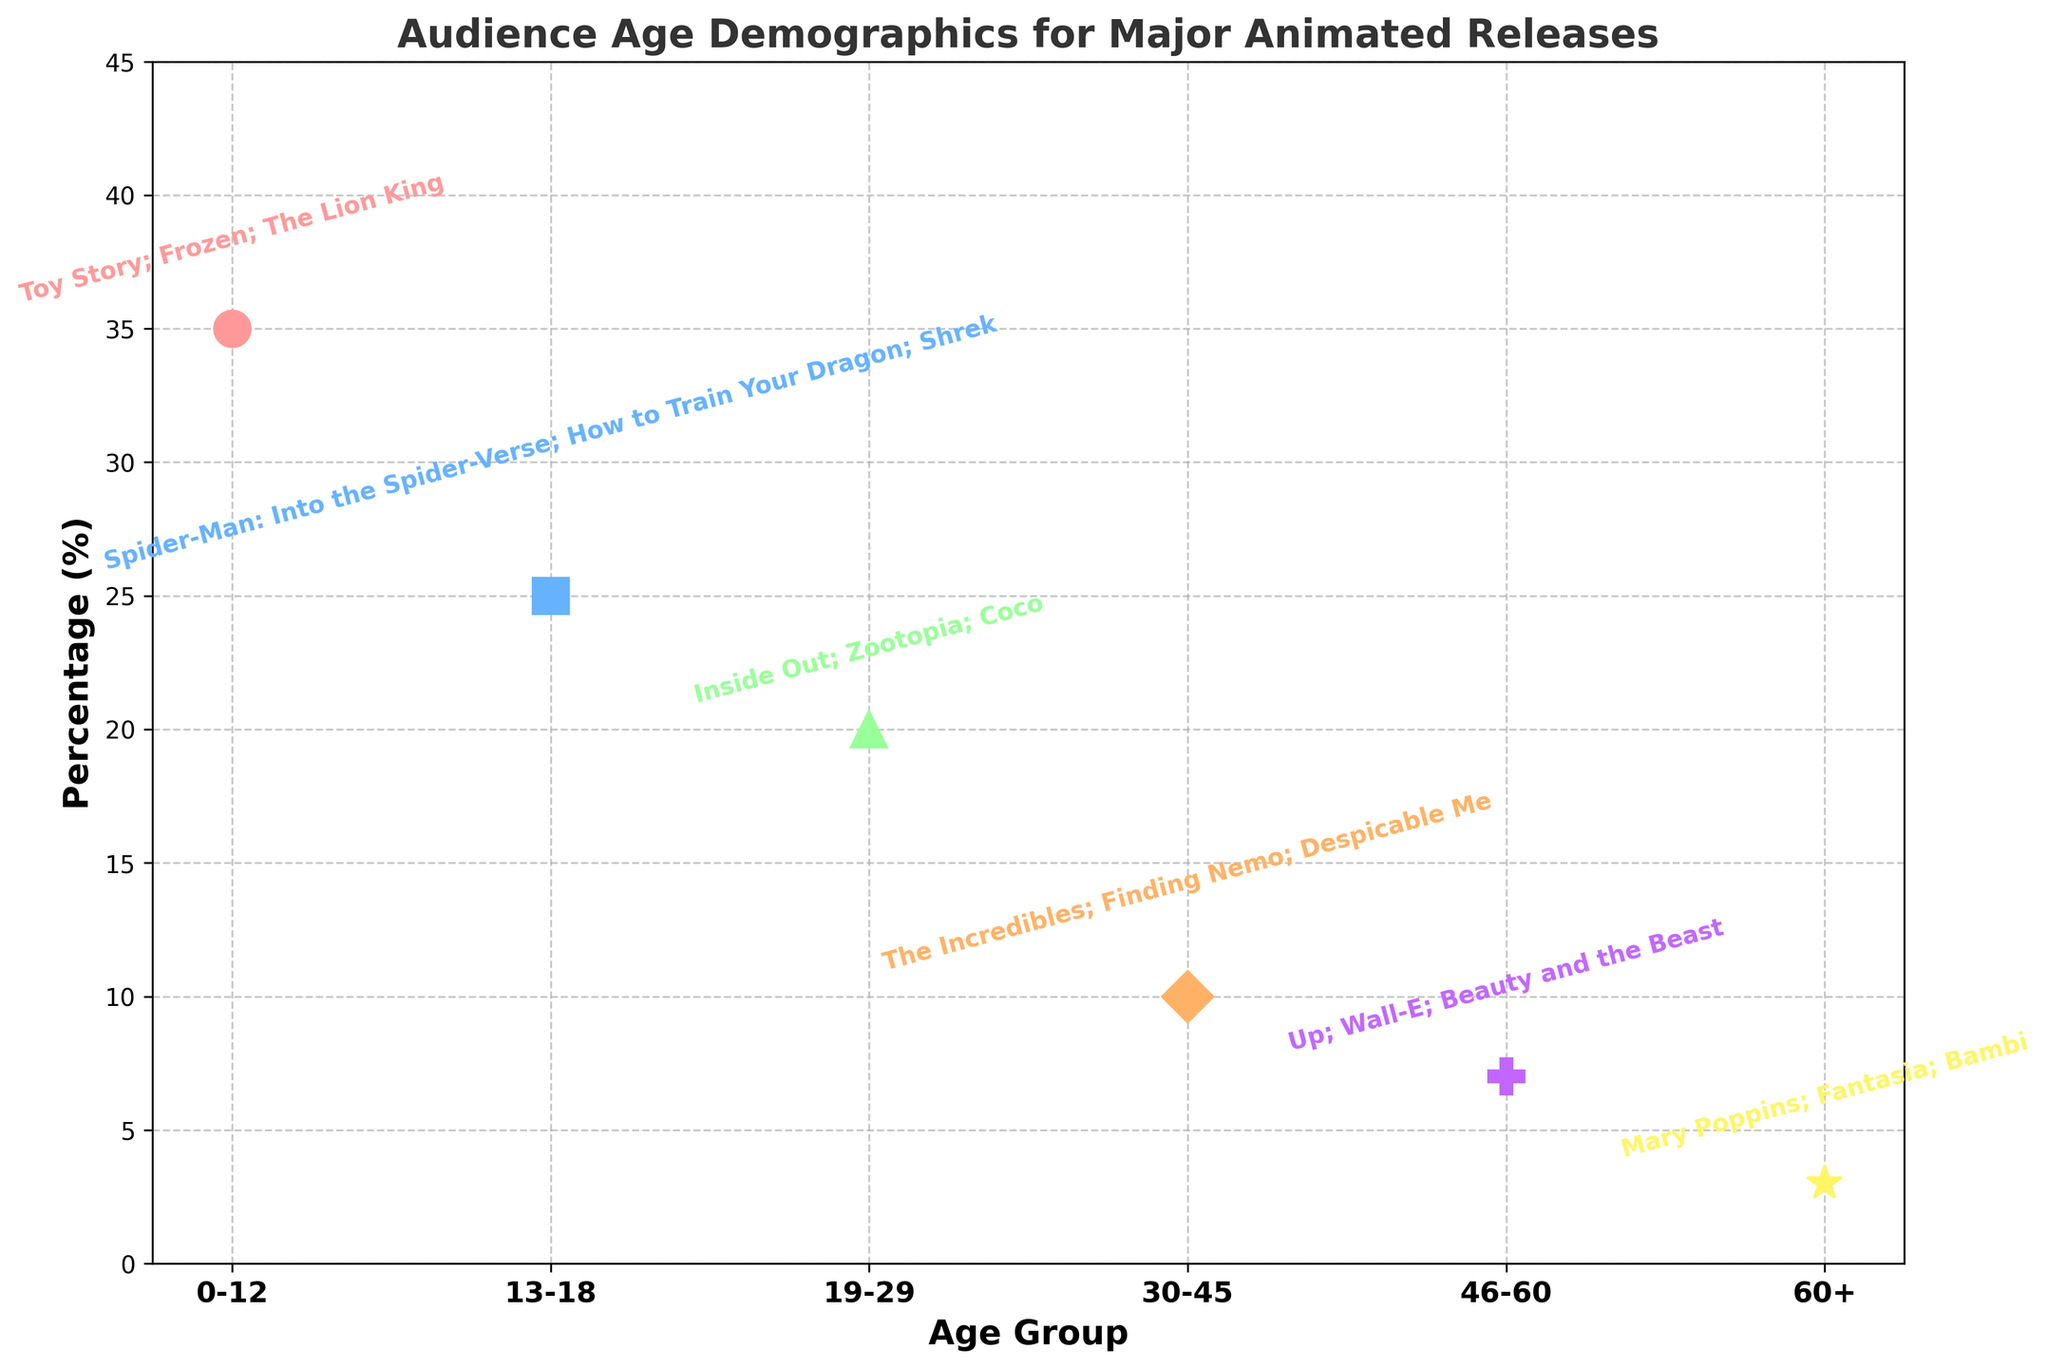Which age group has the highest percentage of the audience? The age group with the highest marker on the y-axis indicates the highest percentage. The '0-12' age group has the highest percentage at 35%.
Answer: 0-12 Which two age groups have the lowest percentages combined? Identify the two age groups with the smallest markers on the y-axis and sum their percentages. The '60+' group (3%) and '46-60' group (7%) have the smallest percentages, summing to 10%.
Answer: 60+ and 46-60 How does the percentage of the '13-18' age group compare to the '19-29' age group? The '13-18' group has a marker at 25% and the '19-29' group has a marker at 20%. 25% is greater than 20%, so the '13-18' group has a higher percentage.
Answer: The '13-18' group has a higher percentage Which age group is characterized by the titles 'Up', 'Wall-E', and 'Beauty and the Beast'? Check the text annotations near the y-axis markers to find the group associated with these titles. These titles are under the '46-60' age group.
Answer: 46-60 What is the sum of the percentages of the '0-12' and '13-18' age groups? Add the percentages of the '0-12' group (35%) and the '13-18' group (25%). The sum is 35% + 25% = 60%.
Answer: 60% What is the visual marker for the '30-45' age group and how is its percentage annotated? Locate the '30-45' group on the x-axis which is marked with a diamond shape (D). Its percentage is annotated as 10% with the titles listed next to it.
Answer: Diamond shape, 10% Which age group watches 'Inside Out' according to the plot? Refer to the text annotations above the marker associated with 'Inside Out'. It's listed under the '19-29' age group.
Answer: 19-29 What color represents the '46-60' age group in the figure? The color next to the '46-60' marker is light purple. This demonstrates that the light purple color represents the '46-60' age group.
Answer: light purple 